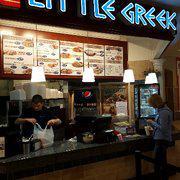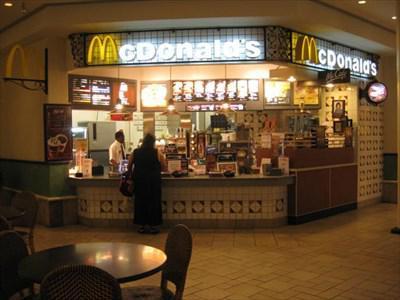The first image is the image on the left, the second image is the image on the right. Analyze the images presented: Is the assertion "The lights in the image on the left are hanging above the counter." valid? Answer yes or no. Yes. The first image is the image on the left, the second image is the image on the right. Considering the images on both sides, is "An unoccupied table sits near a restaurant in one of the images." valid? Answer yes or no. Yes. 